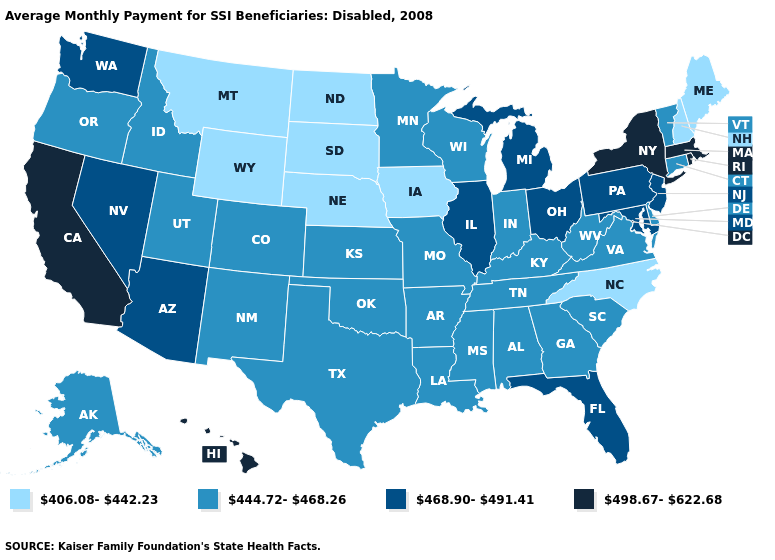Name the states that have a value in the range 498.67-622.68?
Short answer required. California, Hawaii, Massachusetts, New York, Rhode Island. What is the highest value in states that border Virginia?
Be succinct. 468.90-491.41. Does the map have missing data?
Keep it brief. No. Which states have the lowest value in the South?
Quick response, please. North Carolina. Among the states that border South Carolina , which have the highest value?
Give a very brief answer. Georgia. Name the states that have a value in the range 444.72-468.26?
Write a very short answer. Alabama, Alaska, Arkansas, Colorado, Connecticut, Delaware, Georgia, Idaho, Indiana, Kansas, Kentucky, Louisiana, Minnesota, Mississippi, Missouri, New Mexico, Oklahoma, Oregon, South Carolina, Tennessee, Texas, Utah, Vermont, Virginia, West Virginia, Wisconsin. Which states hav the highest value in the South?
Concise answer only. Florida, Maryland. Name the states that have a value in the range 468.90-491.41?
Give a very brief answer. Arizona, Florida, Illinois, Maryland, Michigan, Nevada, New Jersey, Ohio, Pennsylvania, Washington. Does the map have missing data?
Quick response, please. No. Which states have the lowest value in the West?
Write a very short answer. Montana, Wyoming. What is the value of Illinois?
Keep it brief. 468.90-491.41. Which states have the lowest value in the USA?
Give a very brief answer. Iowa, Maine, Montana, Nebraska, New Hampshire, North Carolina, North Dakota, South Dakota, Wyoming. What is the value of Michigan?
Answer briefly. 468.90-491.41. Name the states that have a value in the range 468.90-491.41?
Answer briefly. Arizona, Florida, Illinois, Maryland, Michigan, Nevada, New Jersey, Ohio, Pennsylvania, Washington. 